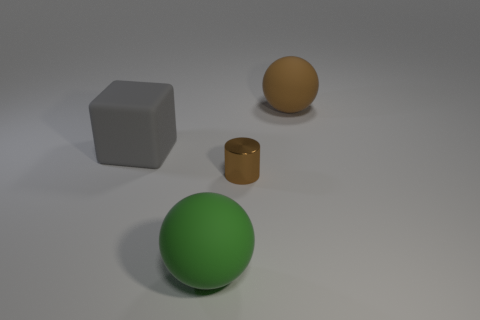Add 2 large gray matte cubes. How many objects exist? 6 Subtract all cylinders. How many objects are left? 3 Add 2 gray rubber cubes. How many gray rubber cubes exist? 3 Subtract 0 cyan spheres. How many objects are left? 4 Subtract all big purple matte cylinders. Subtract all tiny brown cylinders. How many objects are left? 3 Add 2 big cubes. How many big cubes are left? 3 